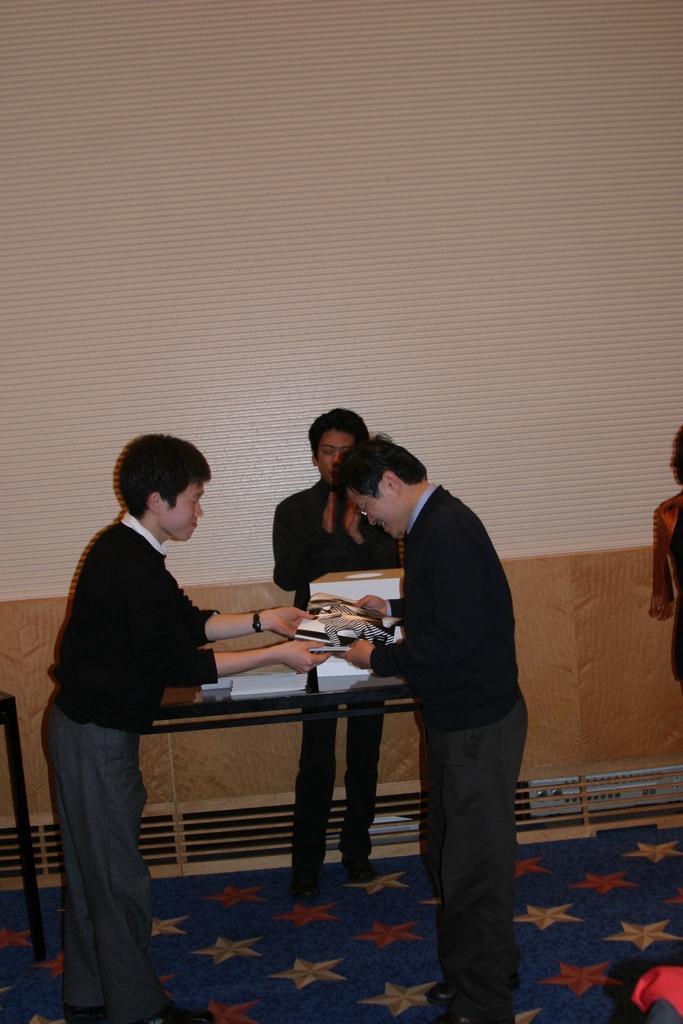In one or two sentences, can you explain what this image depicts? As we can see in the image there are four people and a table. On table there are books and these three people are holding books. 